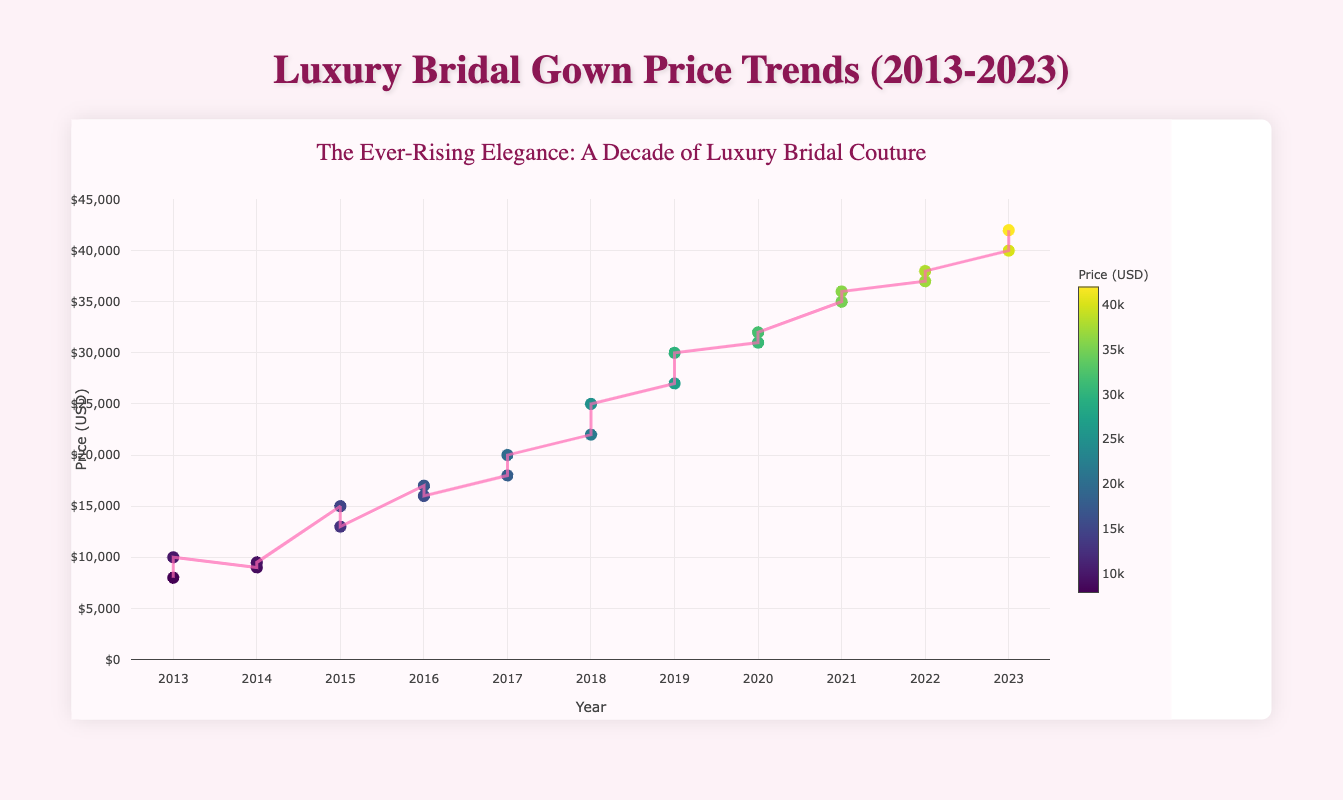What's the price trend of luxury bridal gowns over the last decade? By observing the trend line in the plot, we can see that the prices of luxury bridal gowns have been rising consistently over the last decade. This is indicated by the upward slope of the line.
Answer: Rising What is the price range of luxury bridal gowns in 2013? In the plot, the prices for 2013 can be seen as data points. In 2013, Vera Wang's gown was priced at $8,000 and Oscar de la Renta's gown was priced at $10,000.
Answer: $8,000 - $10,000 Which year does the plot start showing data for luxury bridal gowns? The x-axis represents the years. By looking at the first data point on the plot, we see that the plot starts from 2013.
Answer: 2013 Was there any designer whose gown price reached or exceeded $40,000? If so, who? By looking at the y-axis and finding the data points that reach or exceed $40,000, it shows a data point for 2023. The designers for those years were Naeem Khan and Yolan Cris.
Answer: Naeem Khan, Yolan Cris How did the prices change from 2020 to 2021? By comparing the prices shown in the plot for these years: in 2020, the gown prices were $31,000 and $32,000. In 2021, the prices were $35,000 and $36,000. It shows a clear increase.
Answer: Increased Which year had the highest price for a luxury bridal gown, and what was the price? By examining the highest point on the y-axis, the year with the highest price data point is 2023, at $42,000 (Yolan Cris).
Answer: 2023, $42,000 Calculate the average price of the bridal gowns in 2019. The prices in 2019 are $27,000 and $30,000. The average can be calculated as (27000 + 30000) / 2 = $28,500.
Answer: $28,500 Which designer had the most expensive gown in 2018 and what was its price? By looking at data points for 2018, the highest-priced gowns are $25,000 by Mira Zwillinger.
Answer: Mira Zwillinger, $25,000 How many data points represent bridal gown prices in the whole dataset? By counting the number of data points on the scatter plot, we find there are 22 data points.
Answer: 22 Was there any year where the price stayed the same for two designers? By observing each year, we can check each set of data points. No two designers in one year had the exact same price.
Answer: No 